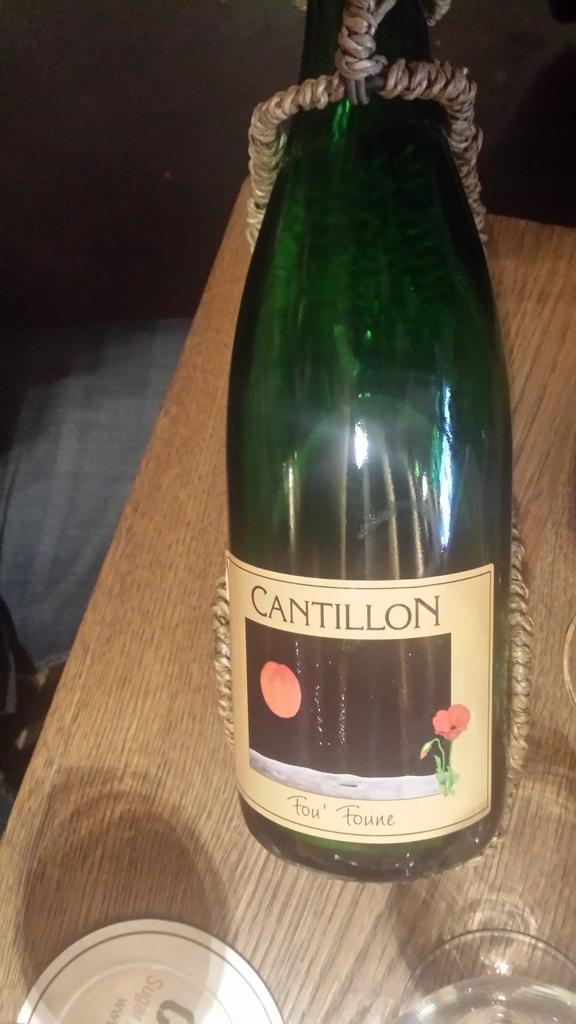<image>
Give a short and clear explanation of the subsequent image. A bottle of Cantillon wine has a rope around it. 